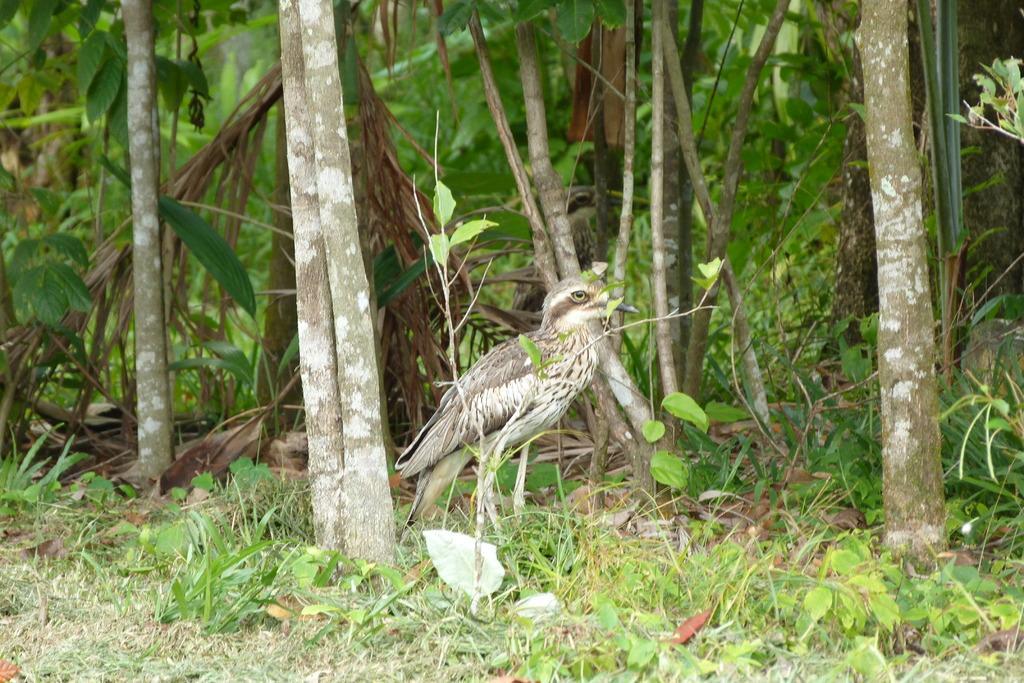Describe this image in one or two sentences. In this image I can see in the middle there is a bird standing and there are trees, at the bottom there is the grass. 